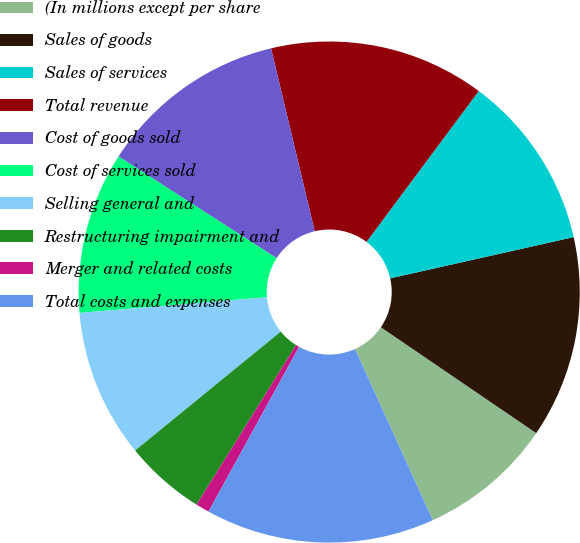Convert chart. <chart><loc_0><loc_0><loc_500><loc_500><pie_chart><fcel>(In millions except per share<fcel>Sales of goods<fcel>Sales of services<fcel>Total revenue<fcel>Cost of goods sold<fcel>Cost of services sold<fcel>Selling general and<fcel>Restructuring impairment and<fcel>Merger and related costs<fcel>Total costs and expenses<nl><fcel>8.7%<fcel>13.04%<fcel>11.3%<fcel>13.91%<fcel>12.17%<fcel>10.43%<fcel>9.57%<fcel>5.22%<fcel>0.88%<fcel>14.78%<nl></chart> 